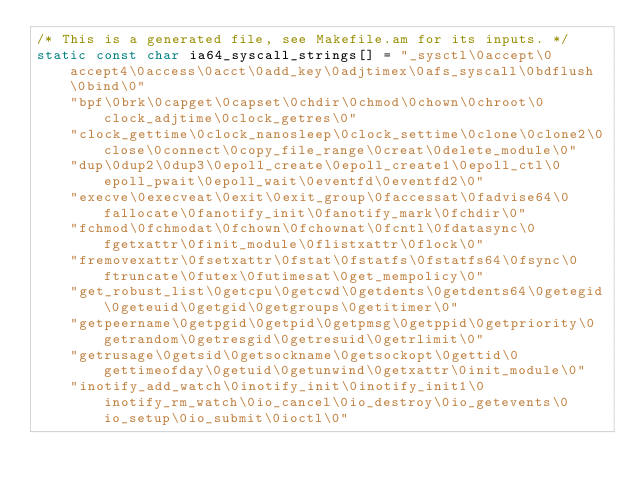<code> <loc_0><loc_0><loc_500><loc_500><_C_>/* This is a generated file, see Makefile.am for its inputs. */
static const char ia64_syscall_strings[] = "_sysctl\0accept\0accept4\0access\0acct\0add_key\0adjtimex\0afs_syscall\0bdflush\0bind\0"
	"bpf\0brk\0capget\0capset\0chdir\0chmod\0chown\0chroot\0clock_adjtime\0clock_getres\0"
	"clock_gettime\0clock_nanosleep\0clock_settime\0clone\0clone2\0close\0connect\0copy_file_range\0creat\0delete_module\0"
	"dup\0dup2\0dup3\0epoll_create\0epoll_create1\0epoll_ctl\0epoll_pwait\0epoll_wait\0eventfd\0eventfd2\0"
	"execve\0execveat\0exit\0exit_group\0faccessat\0fadvise64\0fallocate\0fanotify_init\0fanotify_mark\0fchdir\0"
	"fchmod\0fchmodat\0fchown\0fchownat\0fcntl\0fdatasync\0fgetxattr\0finit_module\0flistxattr\0flock\0"
	"fremovexattr\0fsetxattr\0fstat\0fstatfs\0fstatfs64\0fsync\0ftruncate\0futex\0futimesat\0get_mempolicy\0"
	"get_robust_list\0getcpu\0getcwd\0getdents\0getdents64\0getegid\0geteuid\0getgid\0getgroups\0getitimer\0"
	"getpeername\0getpgid\0getpid\0getpmsg\0getppid\0getpriority\0getrandom\0getresgid\0getresuid\0getrlimit\0"
	"getrusage\0getsid\0getsockname\0getsockopt\0gettid\0gettimeofday\0getuid\0getunwind\0getxattr\0init_module\0"
	"inotify_add_watch\0inotify_init\0inotify_init1\0inotify_rm_watch\0io_cancel\0io_destroy\0io_getevents\0io_setup\0io_submit\0ioctl\0"</code> 